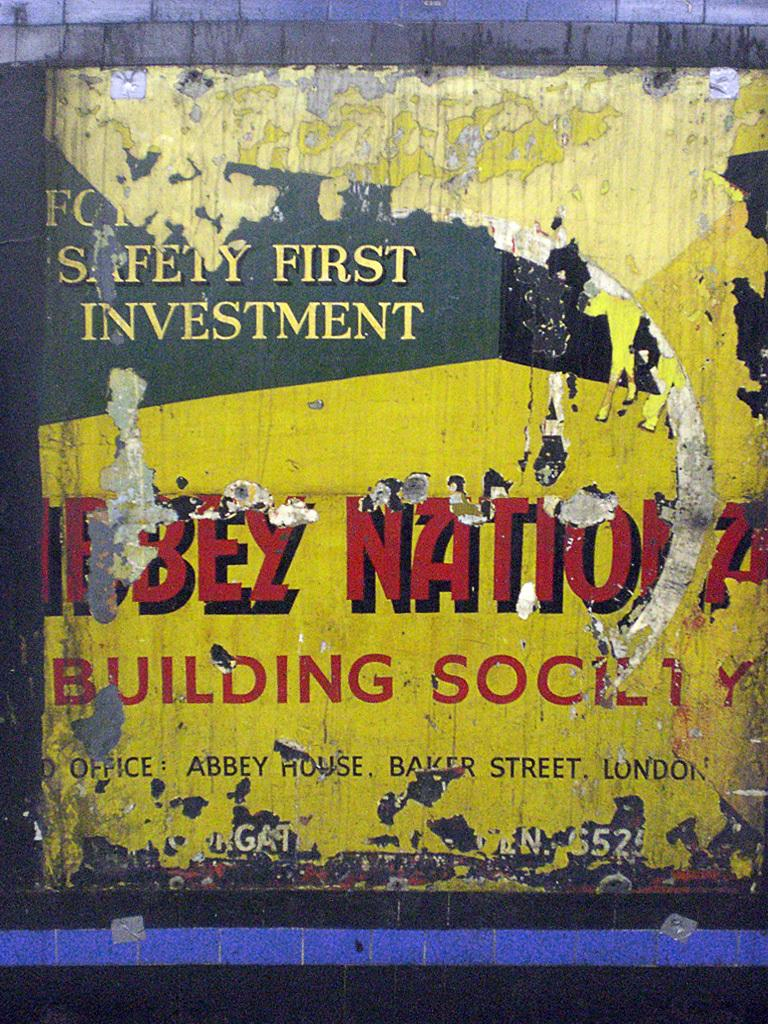Provide a one-sentence caption for the provided image. A ripped up sign on a wall mentioning the words building society. 